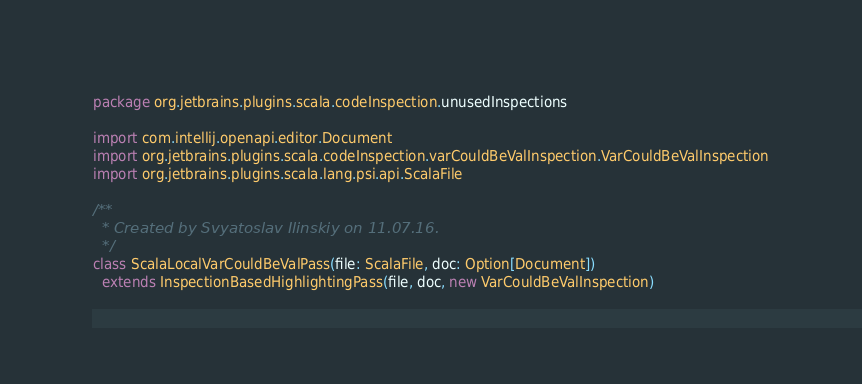<code> <loc_0><loc_0><loc_500><loc_500><_Scala_>package org.jetbrains.plugins.scala.codeInspection.unusedInspections

import com.intellij.openapi.editor.Document
import org.jetbrains.plugins.scala.codeInspection.varCouldBeValInspection.VarCouldBeValInspection
import org.jetbrains.plugins.scala.lang.psi.api.ScalaFile

/**
  * Created by Svyatoslav Ilinskiy on 11.07.16.
  */
class ScalaLocalVarCouldBeValPass(file: ScalaFile, doc: Option[Document])
  extends InspectionBasedHighlightingPass(file, doc, new VarCouldBeValInspection)
</code> 